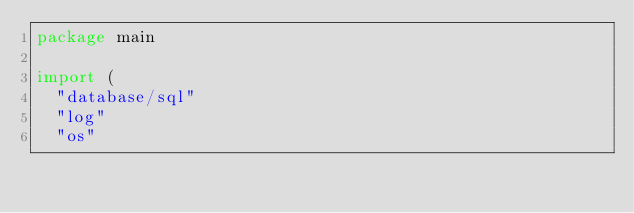Convert code to text. <code><loc_0><loc_0><loc_500><loc_500><_Go_>package main

import (
	"database/sql"
	"log"
	"os"
</code> 